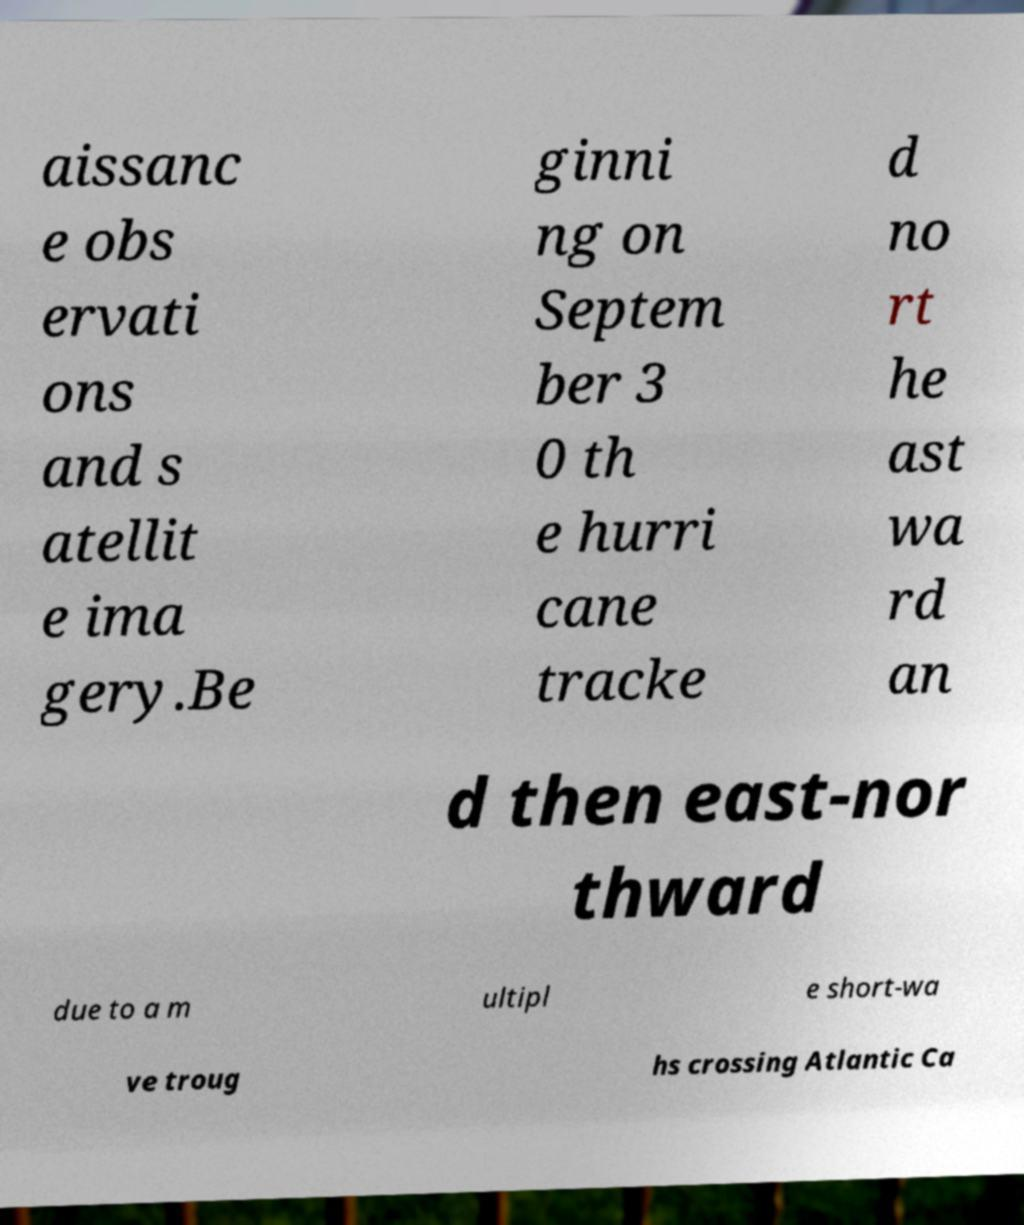Could you assist in decoding the text presented in this image and type it out clearly? aissanc e obs ervati ons and s atellit e ima gery.Be ginni ng on Septem ber 3 0 th e hurri cane tracke d no rt he ast wa rd an d then east-nor thward due to a m ultipl e short-wa ve troug hs crossing Atlantic Ca 